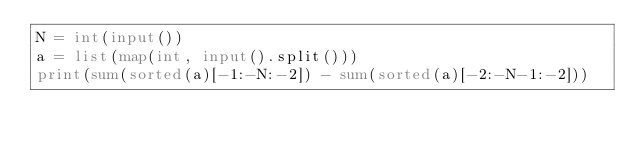Convert code to text. <code><loc_0><loc_0><loc_500><loc_500><_Python_>N = int(input())
a = list(map(int, input().split()))
print(sum(sorted(a)[-1:-N:-2]) - sum(sorted(a)[-2:-N-1:-2]))</code> 